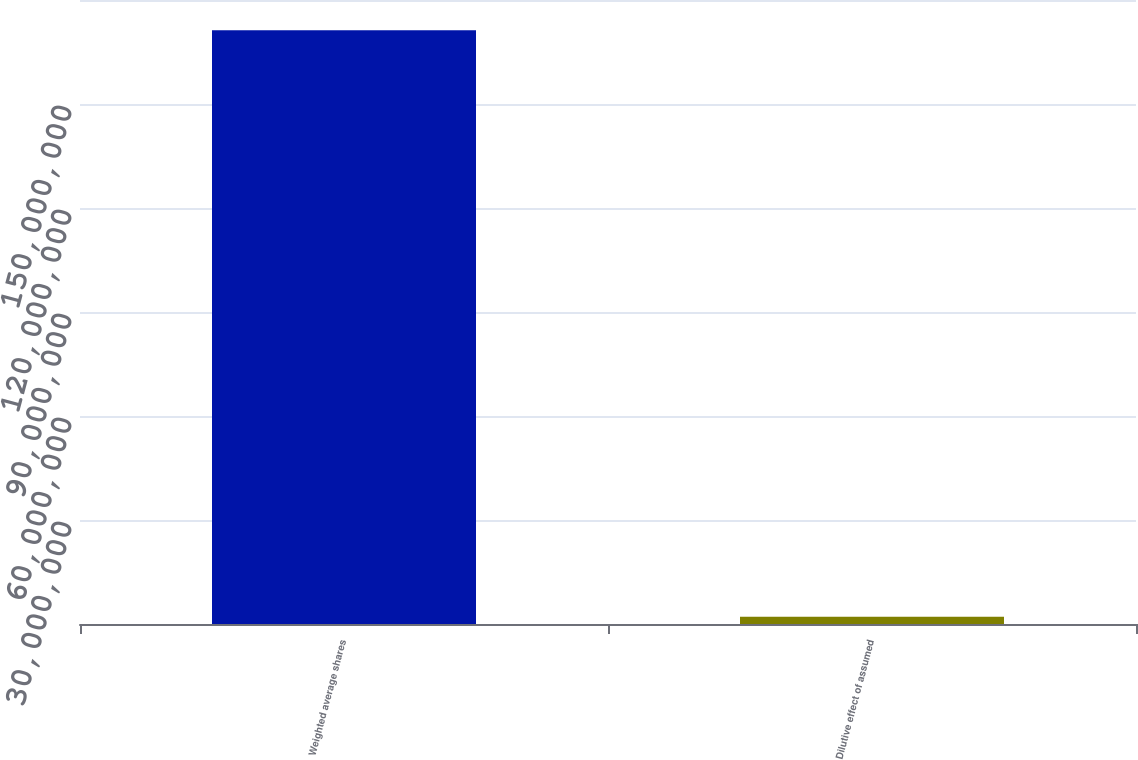<chart> <loc_0><loc_0><loc_500><loc_500><bar_chart><fcel>Weighted average shares<fcel>Dilutive effect of assumed<nl><fcel>1.71254e+08<fcel>2.059e+06<nl></chart> 